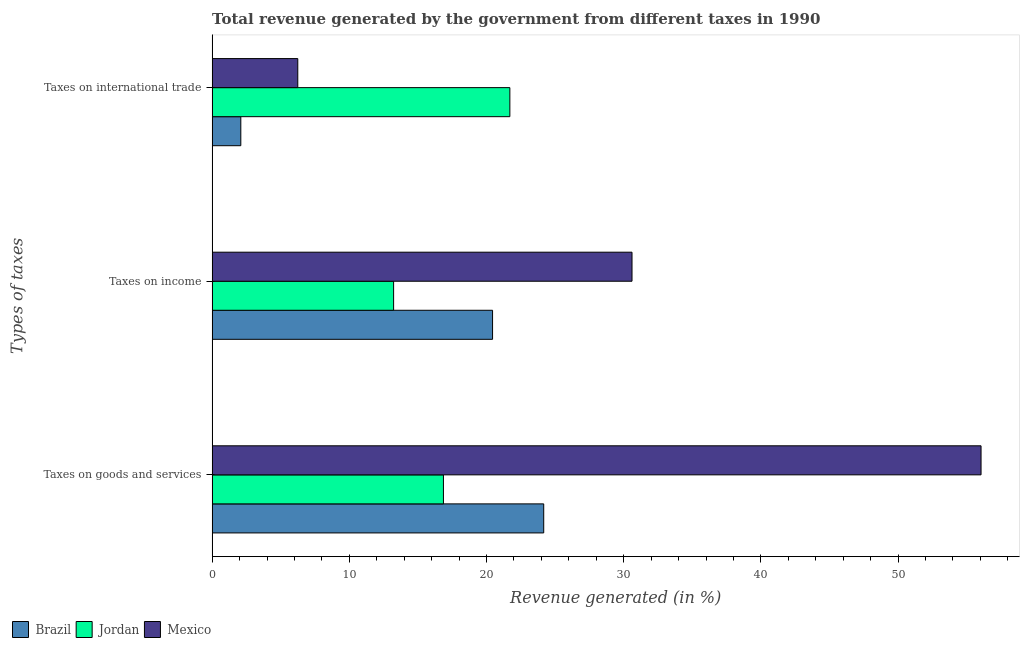Are the number of bars per tick equal to the number of legend labels?
Keep it short and to the point. Yes. How many bars are there on the 2nd tick from the bottom?
Provide a succinct answer. 3. What is the label of the 2nd group of bars from the top?
Provide a succinct answer. Taxes on income. What is the percentage of revenue generated by taxes on income in Jordan?
Give a very brief answer. 13.23. Across all countries, what is the maximum percentage of revenue generated by taxes on income?
Provide a succinct answer. 30.61. Across all countries, what is the minimum percentage of revenue generated by taxes on goods and services?
Make the answer very short. 16.86. In which country was the percentage of revenue generated by taxes on income minimum?
Make the answer very short. Jordan. What is the total percentage of revenue generated by taxes on goods and services in the graph?
Keep it short and to the point. 97.08. What is the difference between the percentage of revenue generated by taxes on income in Brazil and that in Jordan?
Provide a succinct answer. 7.21. What is the difference between the percentage of revenue generated by taxes on income in Brazil and the percentage of revenue generated by tax on international trade in Jordan?
Provide a short and direct response. -1.26. What is the average percentage of revenue generated by tax on international trade per country?
Provide a short and direct response. 10.01. What is the difference between the percentage of revenue generated by taxes on income and percentage of revenue generated by tax on international trade in Brazil?
Your answer should be compact. 18.35. What is the ratio of the percentage of revenue generated by taxes on income in Jordan to that in Mexico?
Provide a succinct answer. 0.43. What is the difference between the highest and the second highest percentage of revenue generated by tax on international trade?
Offer a very short reply. 15.46. What is the difference between the highest and the lowest percentage of revenue generated by tax on international trade?
Ensure brevity in your answer.  19.61. In how many countries, is the percentage of revenue generated by taxes on goods and services greater than the average percentage of revenue generated by taxes on goods and services taken over all countries?
Give a very brief answer. 1. Is the sum of the percentage of revenue generated by taxes on goods and services in Jordan and Brazil greater than the maximum percentage of revenue generated by tax on international trade across all countries?
Offer a very short reply. Yes. What does the 2nd bar from the top in Taxes on international trade represents?
Keep it short and to the point. Jordan. What does the 3rd bar from the bottom in Taxes on income represents?
Your answer should be compact. Mexico. Is it the case that in every country, the sum of the percentage of revenue generated by taxes on goods and services and percentage of revenue generated by taxes on income is greater than the percentage of revenue generated by tax on international trade?
Provide a short and direct response. Yes. How many countries are there in the graph?
Your answer should be compact. 3. What is the difference between two consecutive major ticks on the X-axis?
Provide a succinct answer. 10. Are the values on the major ticks of X-axis written in scientific E-notation?
Offer a terse response. No. What is the title of the graph?
Offer a terse response. Total revenue generated by the government from different taxes in 1990. Does "Nigeria" appear as one of the legend labels in the graph?
Keep it short and to the point. No. What is the label or title of the X-axis?
Make the answer very short. Revenue generated (in %). What is the label or title of the Y-axis?
Offer a very short reply. Types of taxes. What is the Revenue generated (in %) of Brazil in Taxes on goods and services?
Make the answer very short. 24.17. What is the Revenue generated (in %) in Jordan in Taxes on goods and services?
Provide a succinct answer. 16.86. What is the Revenue generated (in %) of Mexico in Taxes on goods and services?
Provide a succinct answer. 56.05. What is the Revenue generated (in %) in Brazil in Taxes on income?
Offer a very short reply. 20.44. What is the Revenue generated (in %) of Jordan in Taxes on income?
Your response must be concise. 13.23. What is the Revenue generated (in %) of Mexico in Taxes on income?
Provide a short and direct response. 30.61. What is the Revenue generated (in %) in Brazil in Taxes on international trade?
Offer a very short reply. 2.09. What is the Revenue generated (in %) in Jordan in Taxes on international trade?
Ensure brevity in your answer.  21.7. What is the Revenue generated (in %) of Mexico in Taxes on international trade?
Provide a succinct answer. 6.24. Across all Types of taxes, what is the maximum Revenue generated (in %) in Brazil?
Your response must be concise. 24.17. Across all Types of taxes, what is the maximum Revenue generated (in %) of Jordan?
Your answer should be very brief. 21.7. Across all Types of taxes, what is the maximum Revenue generated (in %) in Mexico?
Give a very brief answer. 56.05. Across all Types of taxes, what is the minimum Revenue generated (in %) in Brazil?
Ensure brevity in your answer.  2.09. Across all Types of taxes, what is the minimum Revenue generated (in %) in Jordan?
Offer a terse response. 13.23. Across all Types of taxes, what is the minimum Revenue generated (in %) in Mexico?
Make the answer very short. 6.24. What is the total Revenue generated (in %) of Brazil in the graph?
Provide a short and direct response. 46.7. What is the total Revenue generated (in %) of Jordan in the graph?
Keep it short and to the point. 51.79. What is the total Revenue generated (in %) of Mexico in the graph?
Your answer should be compact. 92.9. What is the difference between the Revenue generated (in %) in Brazil in Taxes on goods and services and that in Taxes on income?
Your answer should be very brief. 3.73. What is the difference between the Revenue generated (in %) in Jordan in Taxes on goods and services and that in Taxes on income?
Your response must be concise. 3.63. What is the difference between the Revenue generated (in %) of Mexico in Taxes on goods and services and that in Taxes on income?
Ensure brevity in your answer.  25.44. What is the difference between the Revenue generated (in %) in Brazil in Taxes on goods and services and that in Taxes on international trade?
Your answer should be very brief. 22.08. What is the difference between the Revenue generated (in %) of Jordan in Taxes on goods and services and that in Taxes on international trade?
Your answer should be compact. -4.84. What is the difference between the Revenue generated (in %) in Mexico in Taxes on goods and services and that in Taxes on international trade?
Keep it short and to the point. 49.8. What is the difference between the Revenue generated (in %) in Brazil in Taxes on income and that in Taxes on international trade?
Provide a succinct answer. 18.35. What is the difference between the Revenue generated (in %) of Jordan in Taxes on income and that in Taxes on international trade?
Provide a short and direct response. -8.47. What is the difference between the Revenue generated (in %) in Mexico in Taxes on income and that in Taxes on international trade?
Ensure brevity in your answer.  24.36. What is the difference between the Revenue generated (in %) of Brazil in Taxes on goods and services and the Revenue generated (in %) of Jordan in Taxes on income?
Give a very brief answer. 10.94. What is the difference between the Revenue generated (in %) of Brazil in Taxes on goods and services and the Revenue generated (in %) of Mexico in Taxes on income?
Your answer should be compact. -6.44. What is the difference between the Revenue generated (in %) of Jordan in Taxes on goods and services and the Revenue generated (in %) of Mexico in Taxes on income?
Provide a succinct answer. -13.74. What is the difference between the Revenue generated (in %) in Brazil in Taxes on goods and services and the Revenue generated (in %) in Jordan in Taxes on international trade?
Offer a very short reply. 2.47. What is the difference between the Revenue generated (in %) in Brazil in Taxes on goods and services and the Revenue generated (in %) in Mexico in Taxes on international trade?
Provide a short and direct response. 17.93. What is the difference between the Revenue generated (in %) in Jordan in Taxes on goods and services and the Revenue generated (in %) in Mexico in Taxes on international trade?
Give a very brief answer. 10.62. What is the difference between the Revenue generated (in %) of Brazil in Taxes on income and the Revenue generated (in %) of Jordan in Taxes on international trade?
Keep it short and to the point. -1.26. What is the difference between the Revenue generated (in %) in Brazil in Taxes on income and the Revenue generated (in %) in Mexico in Taxes on international trade?
Give a very brief answer. 14.2. What is the difference between the Revenue generated (in %) in Jordan in Taxes on income and the Revenue generated (in %) in Mexico in Taxes on international trade?
Offer a terse response. 6.98. What is the average Revenue generated (in %) of Brazil per Types of taxes?
Your response must be concise. 15.57. What is the average Revenue generated (in %) of Jordan per Types of taxes?
Your answer should be compact. 17.26. What is the average Revenue generated (in %) in Mexico per Types of taxes?
Your answer should be very brief. 30.97. What is the difference between the Revenue generated (in %) in Brazil and Revenue generated (in %) in Jordan in Taxes on goods and services?
Make the answer very short. 7.31. What is the difference between the Revenue generated (in %) in Brazil and Revenue generated (in %) in Mexico in Taxes on goods and services?
Offer a terse response. -31.88. What is the difference between the Revenue generated (in %) in Jordan and Revenue generated (in %) in Mexico in Taxes on goods and services?
Ensure brevity in your answer.  -39.19. What is the difference between the Revenue generated (in %) of Brazil and Revenue generated (in %) of Jordan in Taxes on income?
Offer a terse response. 7.21. What is the difference between the Revenue generated (in %) in Brazil and Revenue generated (in %) in Mexico in Taxes on income?
Your answer should be compact. -10.16. What is the difference between the Revenue generated (in %) in Jordan and Revenue generated (in %) in Mexico in Taxes on income?
Provide a succinct answer. -17.38. What is the difference between the Revenue generated (in %) of Brazil and Revenue generated (in %) of Jordan in Taxes on international trade?
Give a very brief answer. -19.61. What is the difference between the Revenue generated (in %) of Brazil and Revenue generated (in %) of Mexico in Taxes on international trade?
Offer a very short reply. -4.15. What is the difference between the Revenue generated (in %) of Jordan and Revenue generated (in %) of Mexico in Taxes on international trade?
Your response must be concise. 15.46. What is the ratio of the Revenue generated (in %) of Brazil in Taxes on goods and services to that in Taxes on income?
Your response must be concise. 1.18. What is the ratio of the Revenue generated (in %) of Jordan in Taxes on goods and services to that in Taxes on income?
Your answer should be very brief. 1.27. What is the ratio of the Revenue generated (in %) of Mexico in Taxes on goods and services to that in Taxes on income?
Offer a very short reply. 1.83. What is the ratio of the Revenue generated (in %) of Brazil in Taxes on goods and services to that in Taxes on international trade?
Offer a terse response. 11.56. What is the ratio of the Revenue generated (in %) of Jordan in Taxes on goods and services to that in Taxes on international trade?
Your answer should be compact. 0.78. What is the ratio of the Revenue generated (in %) of Mexico in Taxes on goods and services to that in Taxes on international trade?
Your response must be concise. 8.98. What is the ratio of the Revenue generated (in %) of Brazil in Taxes on income to that in Taxes on international trade?
Offer a very short reply. 9.77. What is the ratio of the Revenue generated (in %) in Jordan in Taxes on income to that in Taxes on international trade?
Make the answer very short. 0.61. What is the ratio of the Revenue generated (in %) of Mexico in Taxes on income to that in Taxes on international trade?
Make the answer very short. 4.9. What is the difference between the highest and the second highest Revenue generated (in %) of Brazil?
Provide a succinct answer. 3.73. What is the difference between the highest and the second highest Revenue generated (in %) of Jordan?
Provide a succinct answer. 4.84. What is the difference between the highest and the second highest Revenue generated (in %) of Mexico?
Ensure brevity in your answer.  25.44. What is the difference between the highest and the lowest Revenue generated (in %) in Brazil?
Provide a succinct answer. 22.08. What is the difference between the highest and the lowest Revenue generated (in %) of Jordan?
Keep it short and to the point. 8.47. What is the difference between the highest and the lowest Revenue generated (in %) in Mexico?
Provide a short and direct response. 49.8. 